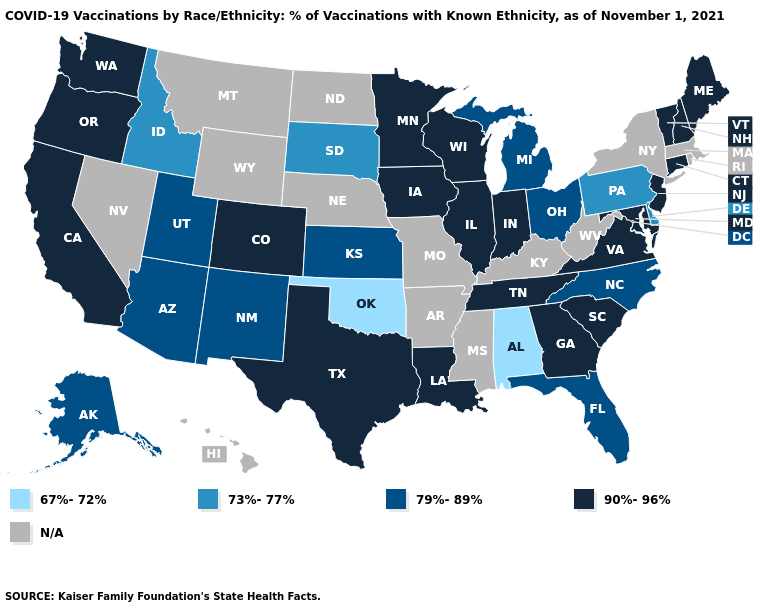Name the states that have a value in the range N/A?
Give a very brief answer. Arkansas, Hawaii, Kentucky, Massachusetts, Mississippi, Missouri, Montana, Nebraska, Nevada, New York, North Dakota, Rhode Island, West Virginia, Wyoming. Does the map have missing data?
Answer briefly. Yes. Does Alabama have the lowest value in the USA?
Concise answer only. Yes. What is the value of Alaska?
Short answer required. 79%-89%. What is the highest value in the South ?
Quick response, please. 90%-96%. Does New Hampshire have the highest value in the Northeast?
Concise answer only. Yes. What is the highest value in states that border Alabama?
Be succinct. 90%-96%. What is the lowest value in states that border Mississippi?
Short answer required. 67%-72%. Does Colorado have the lowest value in the West?
Keep it brief. No. What is the value of Louisiana?
Concise answer only. 90%-96%. Does South Dakota have the lowest value in the MidWest?
Quick response, please. Yes. Does Arizona have the highest value in the West?
Be succinct. No. What is the value of Maine?
Concise answer only. 90%-96%. Does Michigan have the highest value in the MidWest?
Quick response, please. No. Which states have the highest value in the USA?
Write a very short answer. California, Colorado, Connecticut, Georgia, Illinois, Indiana, Iowa, Louisiana, Maine, Maryland, Minnesota, New Hampshire, New Jersey, Oregon, South Carolina, Tennessee, Texas, Vermont, Virginia, Washington, Wisconsin. 